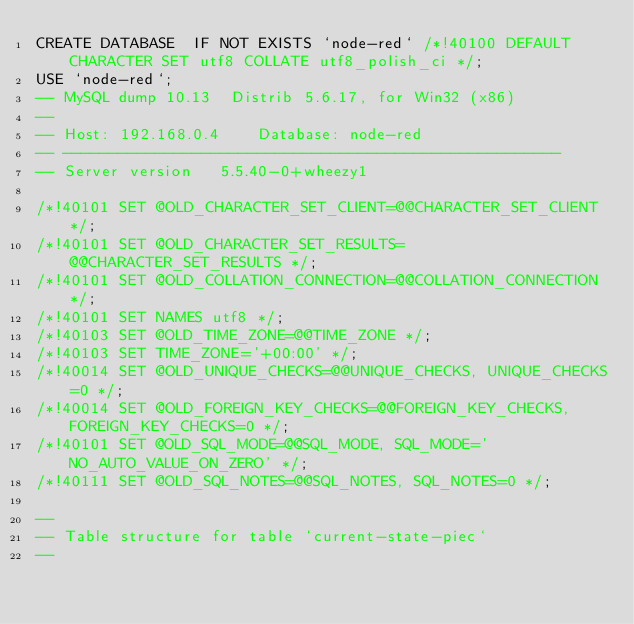Convert code to text. <code><loc_0><loc_0><loc_500><loc_500><_SQL_>CREATE DATABASE  IF NOT EXISTS `node-red` /*!40100 DEFAULT CHARACTER SET utf8 COLLATE utf8_polish_ci */;
USE `node-red`;
-- MySQL dump 10.13  Distrib 5.6.17, for Win32 (x86)
--
-- Host: 192.168.0.4    Database: node-red
-- ------------------------------------------------------
-- Server version	5.5.40-0+wheezy1

/*!40101 SET @OLD_CHARACTER_SET_CLIENT=@@CHARACTER_SET_CLIENT */;
/*!40101 SET @OLD_CHARACTER_SET_RESULTS=@@CHARACTER_SET_RESULTS */;
/*!40101 SET @OLD_COLLATION_CONNECTION=@@COLLATION_CONNECTION */;
/*!40101 SET NAMES utf8 */;
/*!40103 SET @OLD_TIME_ZONE=@@TIME_ZONE */;
/*!40103 SET TIME_ZONE='+00:00' */;
/*!40014 SET @OLD_UNIQUE_CHECKS=@@UNIQUE_CHECKS, UNIQUE_CHECKS=0 */;
/*!40014 SET @OLD_FOREIGN_KEY_CHECKS=@@FOREIGN_KEY_CHECKS, FOREIGN_KEY_CHECKS=0 */;
/*!40101 SET @OLD_SQL_MODE=@@SQL_MODE, SQL_MODE='NO_AUTO_VALUE_ON_ZERO' */;
/*!40111 SET @OLD_SQL_NOTES=@@SQL_NOTES, SQL_NOTES=0 */;

--
-- Table structure for table `current-state-piec`
--
</code> 